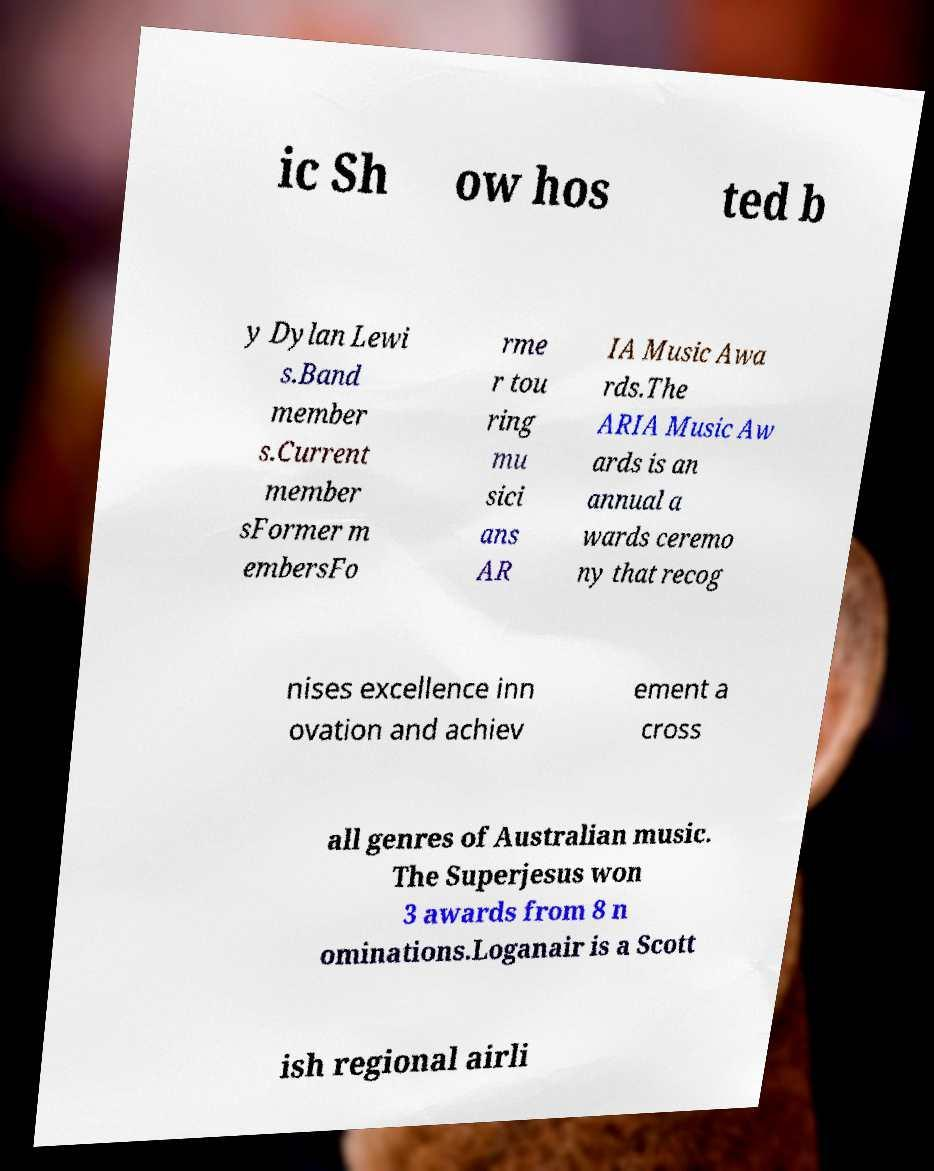Please identify and transcribe the text found in this image. ic Sh ow hos ted b y Dylan Lewi s.Band member s.Current member sFormer m embersFo rme r tou ring mu sici ans AR IA Music Awa rds.The ARIA Music Aw ards is an annual a wards ceremo ny that recog nises excellence inn ovation and achiev ement a cross all genres of Australian music. The Superjesus won 3 awards from 8 n ominations.Loganair is a Scott ish regional airli 